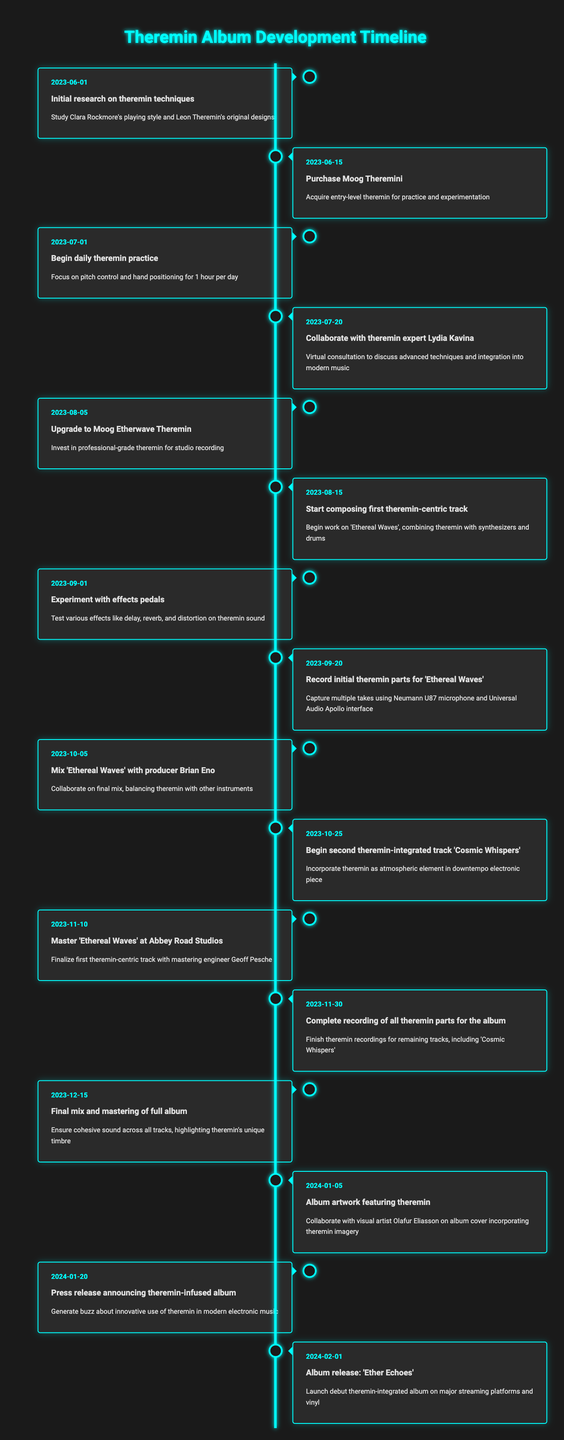What was the first event related to incorporating the theremin? The first event listed in the timeline is "Initial research on theremin techniques," which is dated 2023-06-01.
Answer: Initial research on theremin techniques How many days were spent practicing the theremin from June 1 to July 1, 2023? The period between June 1 and July 1, 2023, is 30 days. During this time, the artist began daily theremin practice on July 1, which suggests they did not practice before that date.
Answer: 30 days Did the artist collaborate with a theremin expert? Yes, the timeline includes an event on July 20, 2023, describing a collaboration with theremin expert Lydia Kavina.
Answer: Yes What is the significance of the date October 5, 2023? On this date, there is an event stating, "Mix 'Ethereal Waves' with producer Brian Eno," marking an important step in the album's development.
Answer: Mixing with Brian Eno Which track was recorded after 'Ethereal Waves'? The timeline shows that after recording 'Ethereal Waves' parts on September 20, 2023, the next track noted is 'Cosmic Whispers,' which work began on October 25, 2023.
Answer: Cosmic Whispers How many total events are listed in the timeline? There are a total of 15 events listed in the timeline, detailing various stages of integrating the theremin into the album.
Answer: 15 events When was the album release planned? The album release is planned for February 1, 2024, as indicated in the final event listed in the timeline.
Answer: February 1, 2024 What is the date of the final mix and mastering of the full album? The final mix and mastering of the full album is scheduled for December 15, 2023, as shown in the timeline.
Answer: December 15, 2023 Did the artist purchase the theremin before starting to practice? Yes, according to the timeline, the artist purchased the Moog Theremini on June 15, 2023, before beginning daily practice on July 1, 2023.
Answer: Yes What was the event immediately before the album artwork collaboration? The event immediately before the album artwork collaboration on January 5, 2024, is the press release announcing the theremin-infused album, dated January 20, 2024.
Answer: Press release on January 20, 2024 